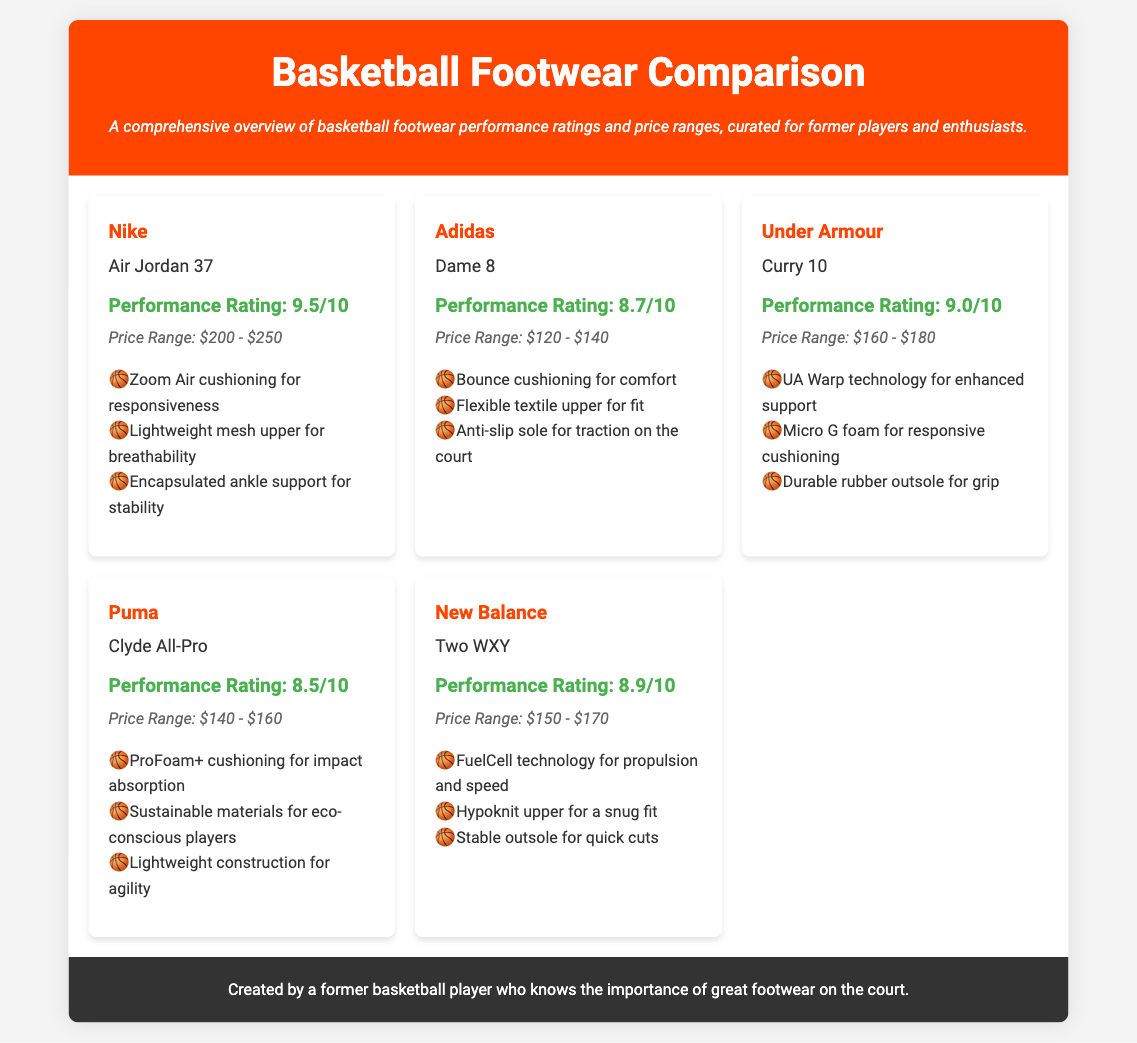What is the performance rating of the Nike Air Jordan 37? The performance rating is stated in the document as 9.5/10.
Answer: 9.5/10 What is the price range of the Adidas Dame 8? The price range is listed in the document as $120 - $140.
Answer: $120 - $140 Which brand offers the Curry 10? The brand is explicitly mentioned as Under Armour in the document.
Answer: Under Armour What technology does the New Balance Two WXY use for propulsion? The document states that it uses FuelCell technology for propulsion and speed.
Answer: FuelCell technology Which footwear has the highest performance rating? The comparison of performance ratings shows that the Nike Air Jordan 37 has the highest rating.
Answer: Nike Air Jordan 37 What is the performance rating of the Puma Clyde All-Pro? The rating is noted as 8.5/10 in the document.
Answer: 8.5/10 Which model features UA Warp technology? The document specifies that the Under Armour Curry 10 features this technology.
Answer: Under Armour Curry 10 What is a common feature among all mentioned footwear? The document describes that all footwear have specific technologies for support and cushioning.
Answer: Support and cushioning technologies 